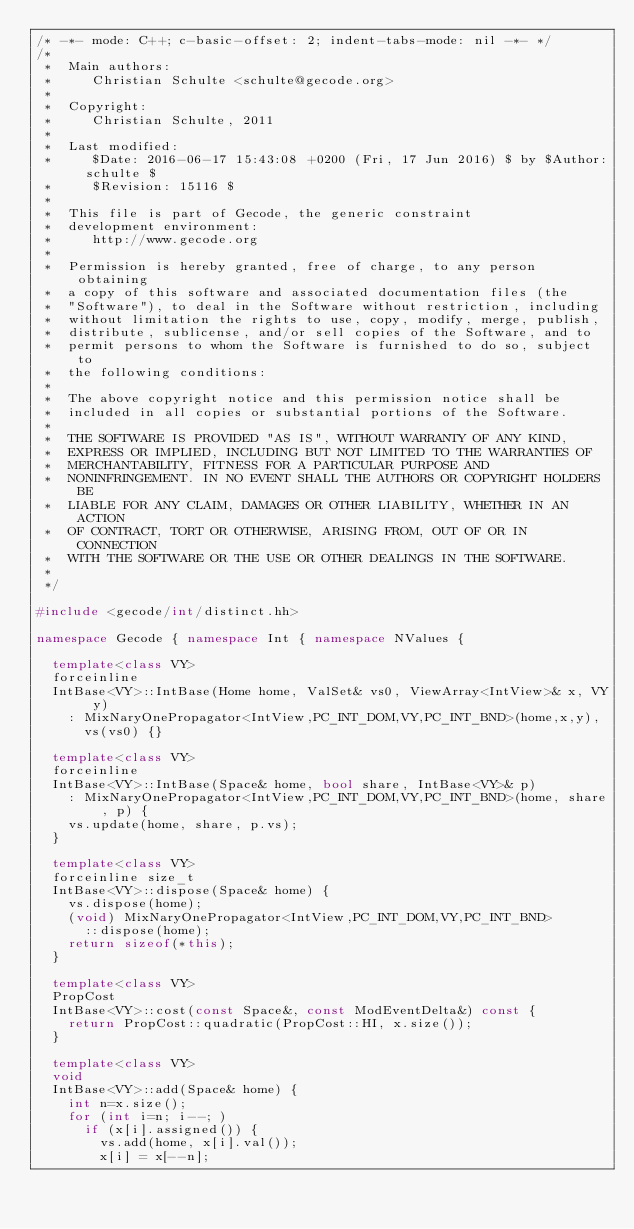<code> <loc_0><loc_0><loc_500><loc_500><_C++_>/* -*- mode: C++; c-basic-offset: 2; indent-tabs-mode: nil -*- */
/*
 *  Main authors:
 *     Christian Schulte <schulte@gecode.org>
 *
 *  Copyright:
 *     Christian Schulte, 2011
 *
 *  Last modified:
 *     $Date: 2016-06-17 15:43:08 +0200 (Fri, 17 Jun 2016) $ by $Author: schulte $
 *     $Revision: 15116 $
 *
 *  This file is part of Gecode, the generic constraint
 *  development environment:
 *     http://www.gecode.org
 *
 *  Permission is hereby granted, free of charge, to any person obtaining
 *  a copy of this software and associated documentation files (the
 *  "Software"), to deal in the Software without restriction, including
 *  without limitation the rights to use, copy, modify, merge, publish,
 *  distribute, sublicense, and/or sell copies of the Software, and to
 *  permit persons to whom the Software is furnished to do so, subject to
 *  the following conditions:
 *
 *  The above copyright notice and this permission notice shall be
 *  included in all copies or substantial portions of the Software.
 *
 *  THE SOFTWARE IS PROVIDED "AS IS", WITHOUT WARRANTY OF ANY KIND,
 *  EXPRESS OR IMPLIED, INCLUDING BUT NOT LIMITED TO THE WARRANTIES OF
 *  MERCHANTABILITY, FITNESS FOR A PARTICULAR PURPOSE AND
 *  NONINFRINGEMENT. IN NO EVENT SHALL THE AUTHORS OR COPYRIGHT HOLDERS BE
 *  LIABLE FOR ANY CLAIM, DAMAGES OR OTHER LIABILITY, WHETHER IN AN ACTION
 *  OF CONTRACT, TORT OR OTHERWISE, ARISING FROM, OUT OF OR IN CONNECTION
 *  WITH THE SOFTWARE OR THE USE OR OTHER DEALINGS IN THE SOFTWARE.
 *
 */

#include <gecode/int/distinct.hh>

namespace Gecode { namespace Int { namespace NValues {

  template<class VY>
  forceinline
  IntBase<VY>::IntBase(Home home, ValSet& vs0, ViewArray<IntView>& x, VY y)
    : MixNaryOnePropagator<IntView,PC_INT_DOM,VY,PC_INT_BND>(home,x,y),
      vs(vs0) {}

  template<class VY>
  forceinline
  IntBase<VY>::IntBase(Space& home, bool share, IntBase<VY>& p)
    : MixNaryOnePropagator<IntView,PC_INT_DOM,VY,PC_INT_BND>(home, share, p) {
    vs.update(home, share, p.vs);
  }

  template<class VY>
  forceinline size_t
  IntBase<VY>::dispose(Space& home) {
    vs.dispose(home);
    (void) MixNaryOnePropagator<IntView,PC_INT_DOM,VY,PC_INT_BND>
      ::dispose(home);
    return sizeof(*this);
  }

  template<class VY>
  PropCost
  IntBase<VY>::cost(const Space&, const ModEventDelta&) const {
    return PropCost::quadratic(PropCost::HI, x.size());
  }

  template<class VY>
  void
  IntBase<VY>::add(Space& home) {
    int n=x.size();
    for (int i=n; i--; )
      if (x[i].assigned()) {
        vs.add(home, x[i].val());
        x[i] = x[--n];</code> 